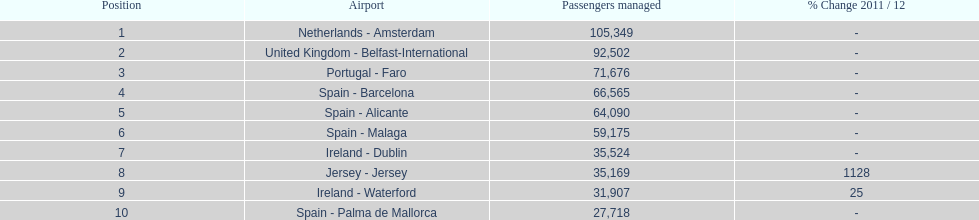How many passengers are going to or coming from spain? 217,548. 